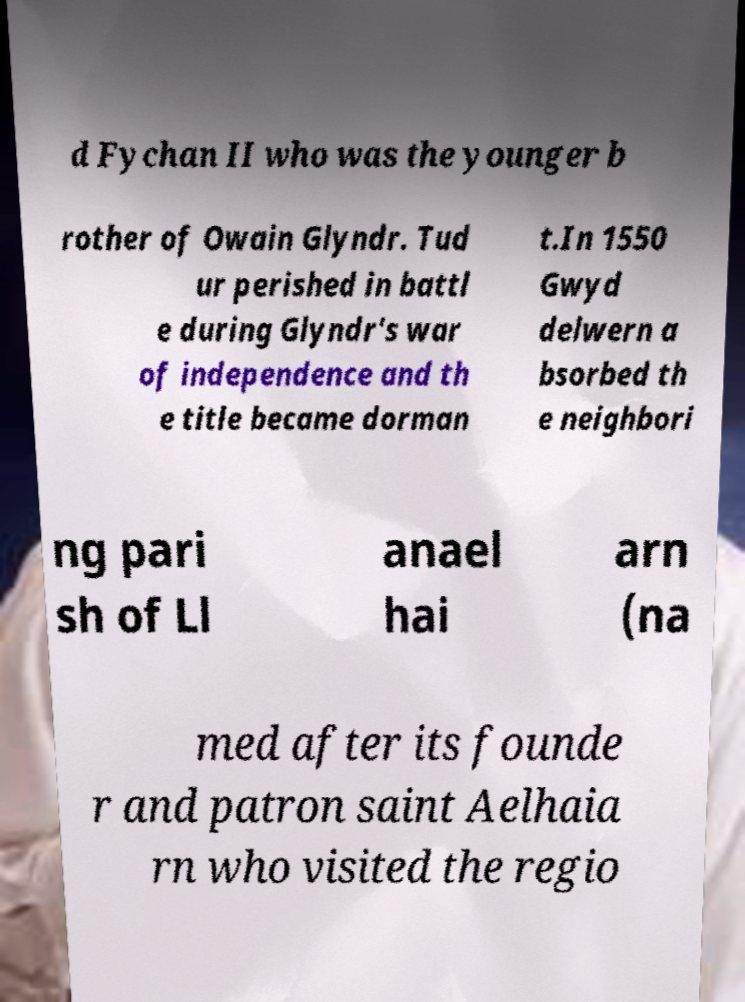I need the written content from this picture converted into text. Can you do that? d Fychan II who was the younger b rother of Owain Glyndr. Tud ur perished in battl e during Glyndr's war of independence and th e title became dorman t.In 1550 Gwyd delwern a bsorbed th e neighbori ng pari sh of Ll anael hai arn (na med after its founde r and patron saint Aelhaia rn who visited the regio 